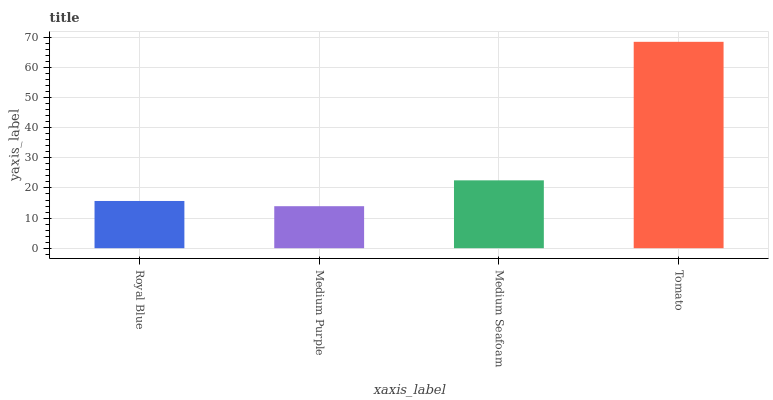Is Medium Purple the minimum?
Answer yes or no. Yes. Is Tomato the maximum?
Answer yes or no. Yes. Is Medium Seafoam the minimum?
Answer yes or no. No. Is Medium Seafoam the maximum?
Answer yes or no. No. Is Medium Seafoam greater than Medium Purple?
Answer yes or no. Yes. Is Medium Purple less than Medium Seafoam?
Answer yes or no. Yes. Is Medium Purple greater than Medium Seafoam?
Answer yes or no. No. Is Medium Seafoam less than Medium Purple?
Answer yes or no. No. Is Medium Seafoam the high median?
Answer yes or no. Yes. Is Royal Blue the low median?
Answer yes or no. Yes. Is Royal Blue the high median?
Answer yes or no. No. Is Medium Seafoam the low median?
Answer yes or no. No. 